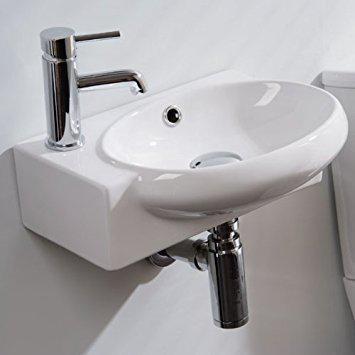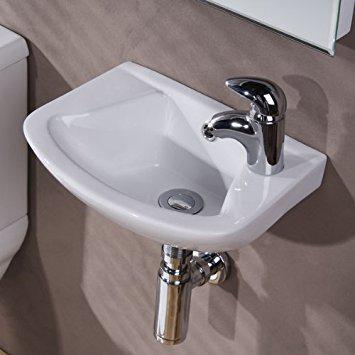The first image is the image on the left, the second image is the image on the right. For the images displayed, is the sentence "The sink on the left fits in a corner, and the sink on the right includes a spout mounted to a rectangular white component." factually correct? Answer yes or no. No. 